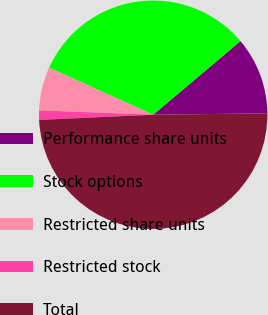<chart> <loc_0><loc_0><loc_500><loc_500><pie_chart><fcel>Performance share units<fcel>Stock options<fcel>Restricted share units<fcel>Restricted stock<fcel>Total<nl><fcel>10.96%<fcel>32.09%<fcel>6.15%<fcel>1.34%<fcel>49.47%<nl></chart> 